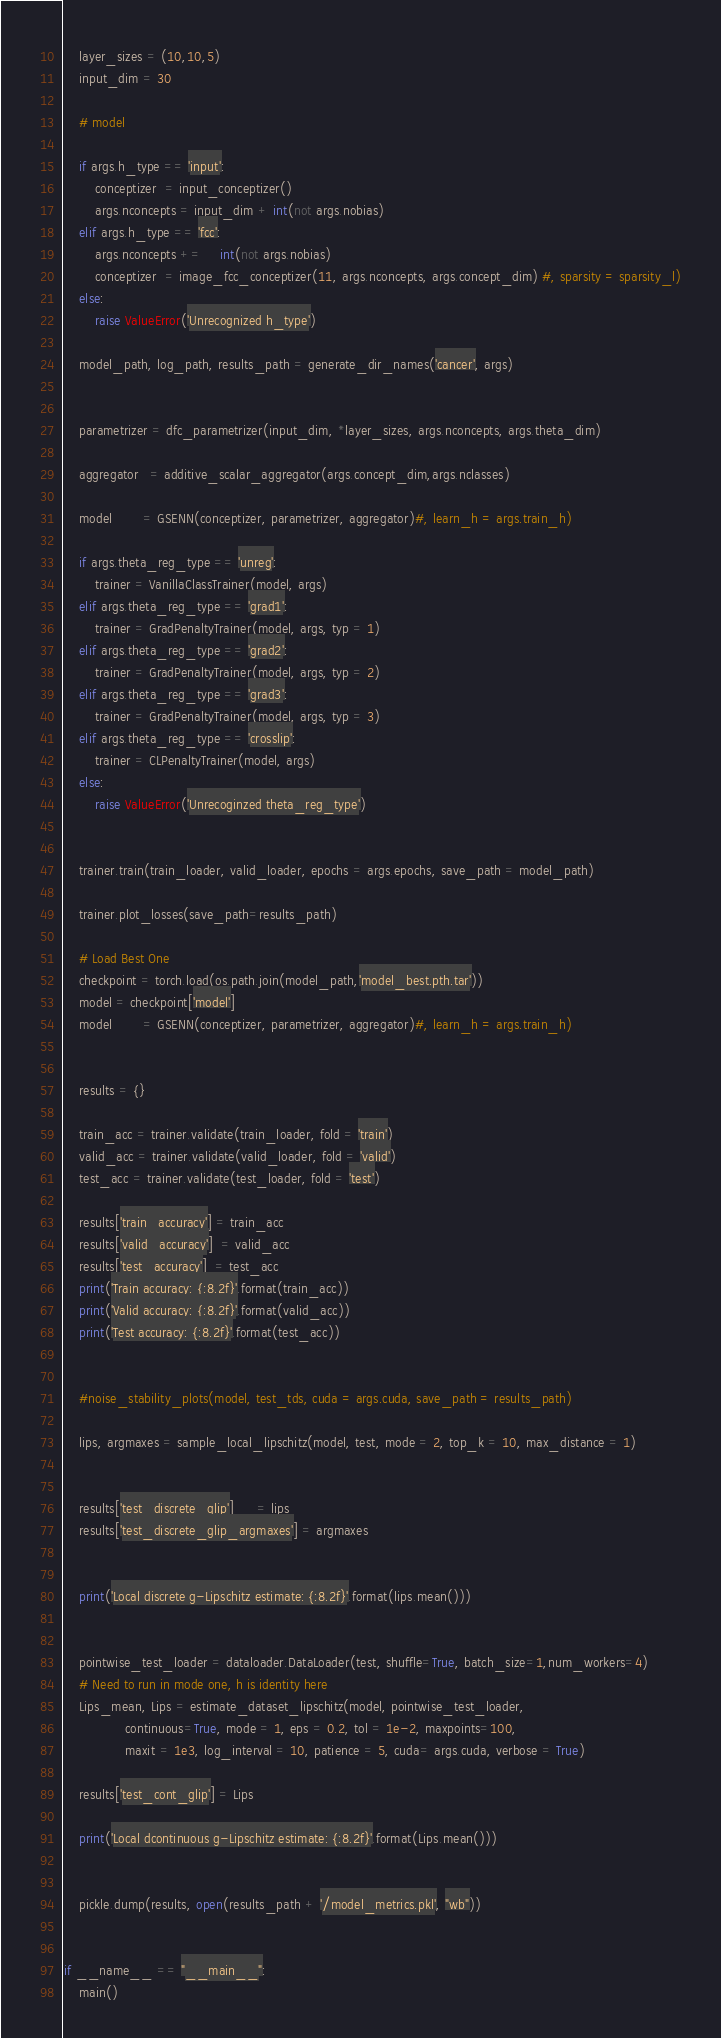Convert code to text. <code><loc_0><loc_0><loc_500><loc_500><_Python_>    layer_sizes = (10,10,5)
    input_dim = 30

    # model

    if args.h_type == 'input':
        conceptizer  = input_conceptizer()
        args.nconcepts = input_dim + int(not args.nobias)
    elif args.h_type == 'fcc':
        args.nconcepts +=     int(not args.nobias)
        conceptizer  = image_fcc_conceptizer(11, args.nconcepts, args.concept_dim) #, sparsity = sparsity_l)
    else:
        raise ValueError('Unrecognized h_type')

    model_path, log_path, results_path = generate_dir_names('cancer', args)


    parametrizer = dfc_parametrizer(input_dim, *layer_sizes, args.nconcepts, args.theta_dim)

    aggregator   = additive_scalar_aggregator(args.concept_dim,args.nclasses)

    model        = GSENN(conceptizer, parametrizer, aggregator)#, learn_h = args.train_h)

    if args.theta_reg_type == 'unreg':
        trainer = VanillaClassTrainer(model, args)
    elif args.theta_reg_type == 'grad1':
        trainer = GradPenaltyTrainer(model, args, typ = 1)
    elif args.theta_reg_type == 'grad2':
        trainer = GradPenaltyTrainer(model, args, typ = 2)
    elif args.theta_reg_type == 'grad3':
        trainer = GradPenaltyTrainer(model, args, typ = 3)
    elif args.theta_reg_type == 'crosslip':
        trainer = CLPenaltyTrainer(model, args)
    else:
        raise ValueError('Unrecoginzed theta_reg_type')


    trainer.train(train_loader, valid_loader, epochs = args.epochs, save_path = model_path)

    trainer.plot_losses(save_path=results_path)

    # Load Best One
    checkpoint = torch.load(os.path.join(model_path,'model_best.pth.tar'))
    model = checkpoint['model']
    model        = GSENN(conceptizer, parametrizer, aggregator)#, learn_h = args.train_h)


    results = {}

    train_acc = trainer.validate(train_loader, fold = 'train')
    valid_acc = trainer.validate(valid_loader, fold = 'valid')
    test_acc = trainer.validate(test_loader, fold = 'test')

    results['train_accuracy'] = train_acc
    results['valid_accuracy']  = valid_acc
    results['test_accuracy']  = test_acc
    print('Train accuracy: {:8.2f}'.format(train_acc))
    print('Valid accuracy: {:8.2f}'.format(valid_acc))
    print('Test accuracy: {:8.2f}'.format(test_acc))


    #noise_stability_plots(model, test_tds, cuda = args.cuda, save_path = results_path)

    lips, argmaxes = sample_local_lipschitz(model, test, mode = 2, top_k = 10, max_distance = 1)


    results['test_discrete_glip']      = lips
    results['test_discrete_glip_argmaxes'] = argmaxes


    print('Local discrete g-Lipschitz estimate: {:8.2f}'.format(lips.mean()))


    pointwise_test_loader = dataloader.DataLoader(test, shuffle=True, batch_size=1,num_workers=4)
    # Need to run in mode one, h is identity here
    Lips_mean, Lips = estimate_dataset_lipschitz(model, pointwise_test_loader,
                continuous=True, mode = 1, eps = 0.2, tol = 1e-2, maxpoints=100,
                maxit = 1e3, log_interval = 10, patience = 5, cuda= args.cuda, verbose = True)

    results['test_cont_glip'] = Lips

    print('Local dcontinuous g-Lipschitz estimate: {:8.2f}'.format(Lips.mean()))


    pickle.dump(results, open(results_path + '/model_metrics.pkl', "wb"))


if __name__ == "__main__":
    main()
</code> 